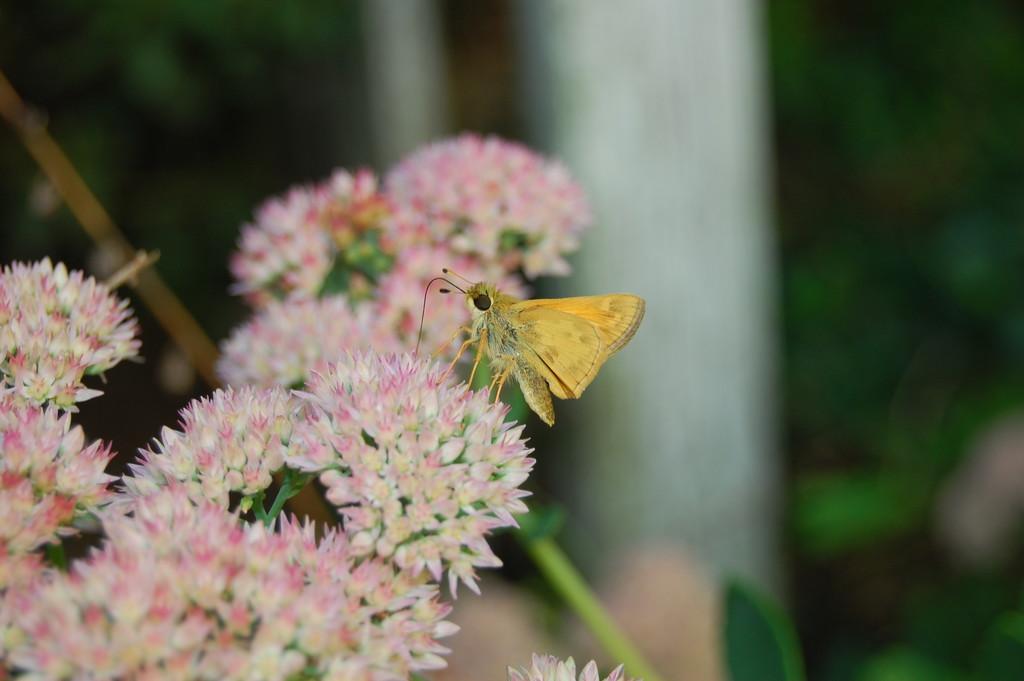Could you give a brief overview of what you see in this image? On the left side of this image I can see few flowers. On the flower there is a butterfly which is facing towards the left side. The background is blurred. 